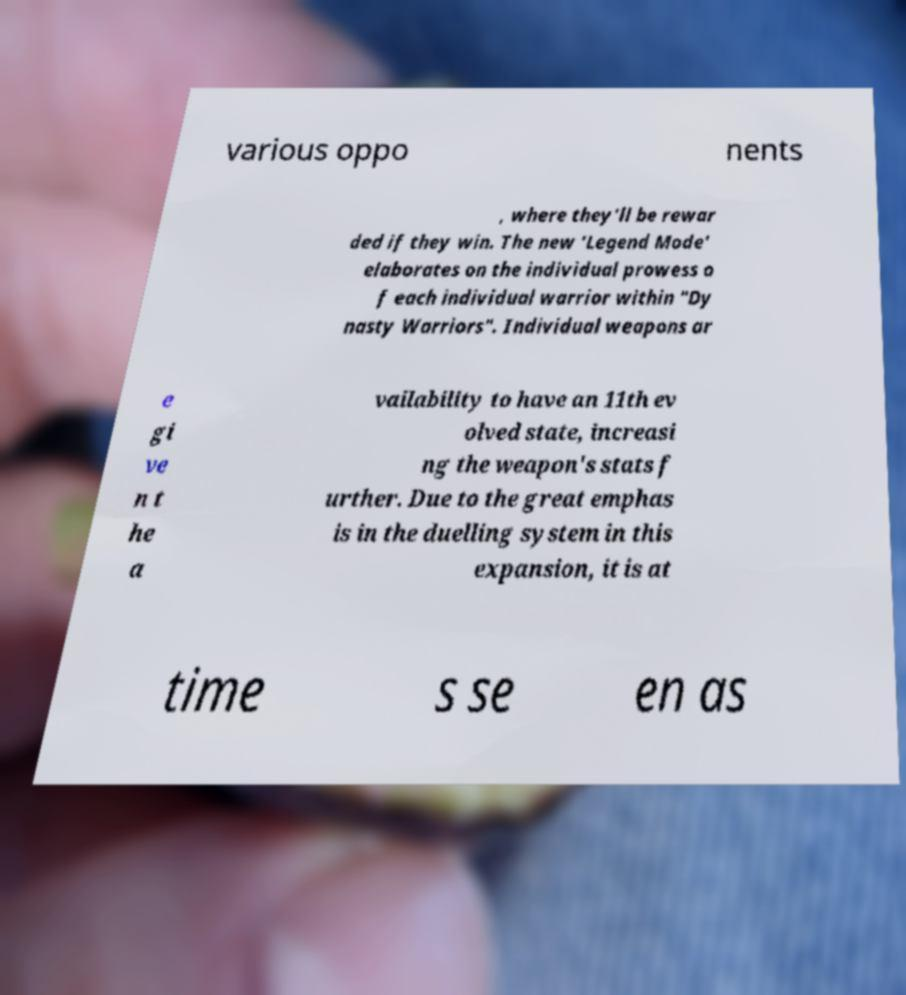I need the written content from this picture converted into text. Can you do that? various oppo nents , where they'll be rewar ded if they win. The new 'Legend Mode' elaborates on the individual prowess o f each individual warrior within "Dy nasty Warriors". Individual weapons ar e gi ve n t he a vailability to have an 11th ev olved state, increasi ng the weapon's stats f urther. Due to the great emphas is in the duelling system in this expansion, it is at time s se en as 